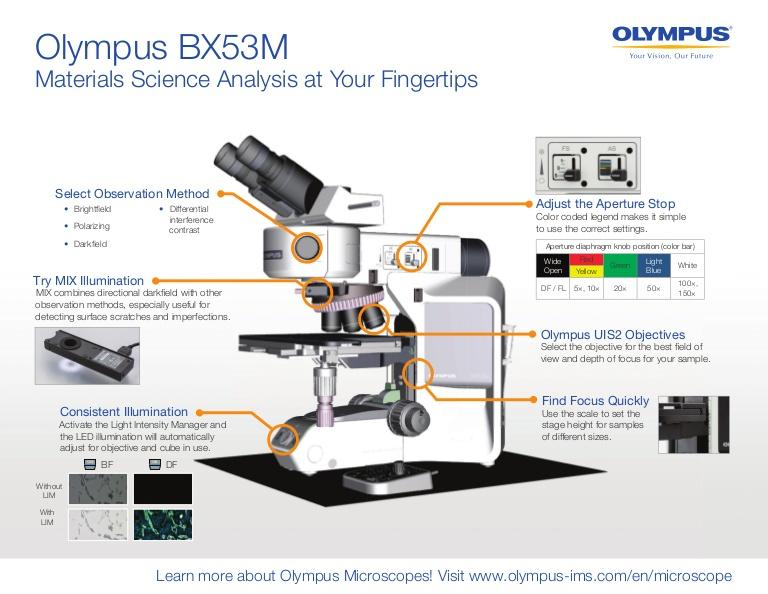Identify some key points in this picture. In the Olympus BX53M microscope, there are two types of lighting: MIX and consistent. 